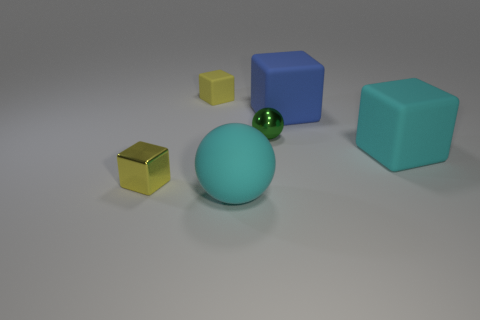What number of tiny objects have the same material as the large ball?
Provide a short and direct response. 1. What number of objects are matte blocks that are left of the big blue rubber block or cyan objects?
Your response must be concise. 3. The cyan matte cube is what size?
Make the answer very short. Large. What is the material of the big cyan object that is to the right of the small thing to the right of the tiny yellow matte object?
Offer a terse response. Rubber. There is a ball that is in front of the yellow metal block; is its size the same as the big blue matte object?
Your response must be concise. Yes. Is there another block that has the same color as the metallic cube?
Make the answer very short. Yes. What number of things are either large blocks that are behind the small metallic sphere or things that are on the right side of the metallic ball?
Offer a very short reply. 2. Is the color of the tiny metal sphere the same as the small rubber thing?
Offer a very short reply. No. There is another thing that is the same color as the small rubber object; what material is it?
Provide a short and direct response. Metal. Are there fewer blue things that are left of the yellow matte block than tiny green spheres in front of the large cyan matte sphere?
Provide a short and direct response. No. 